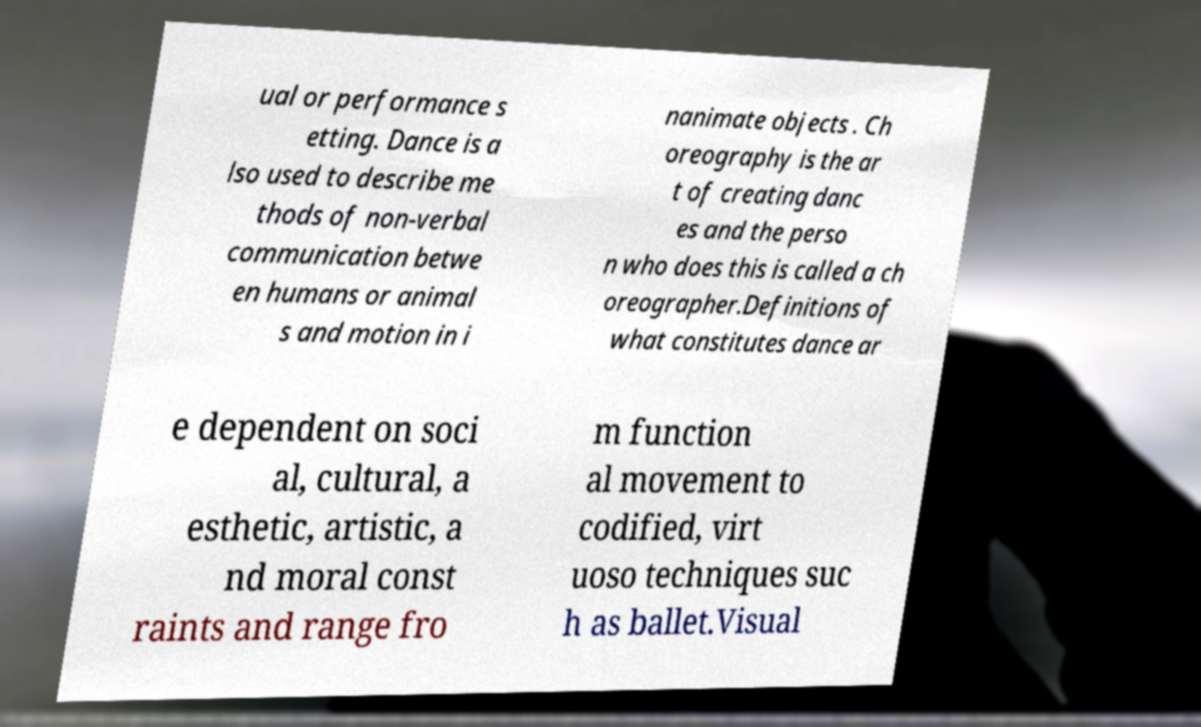Could you extract and type out the text from this image? ual or performance s etting. Dance is a lso used to describe me thods of non-verbal communication betwe en humans or animal s and motion in i nanimate objects . Ch oreography is the ar t of creating danc es and the perso n who does this is called a ch oreographer.Definitions of what constitutes dance ar e dependent on soci al, cultural, a esthetic, artistic, a nd moral const raints and range fro m function al movement to codified, virt uoso techniques suc h as ballet.Visual 